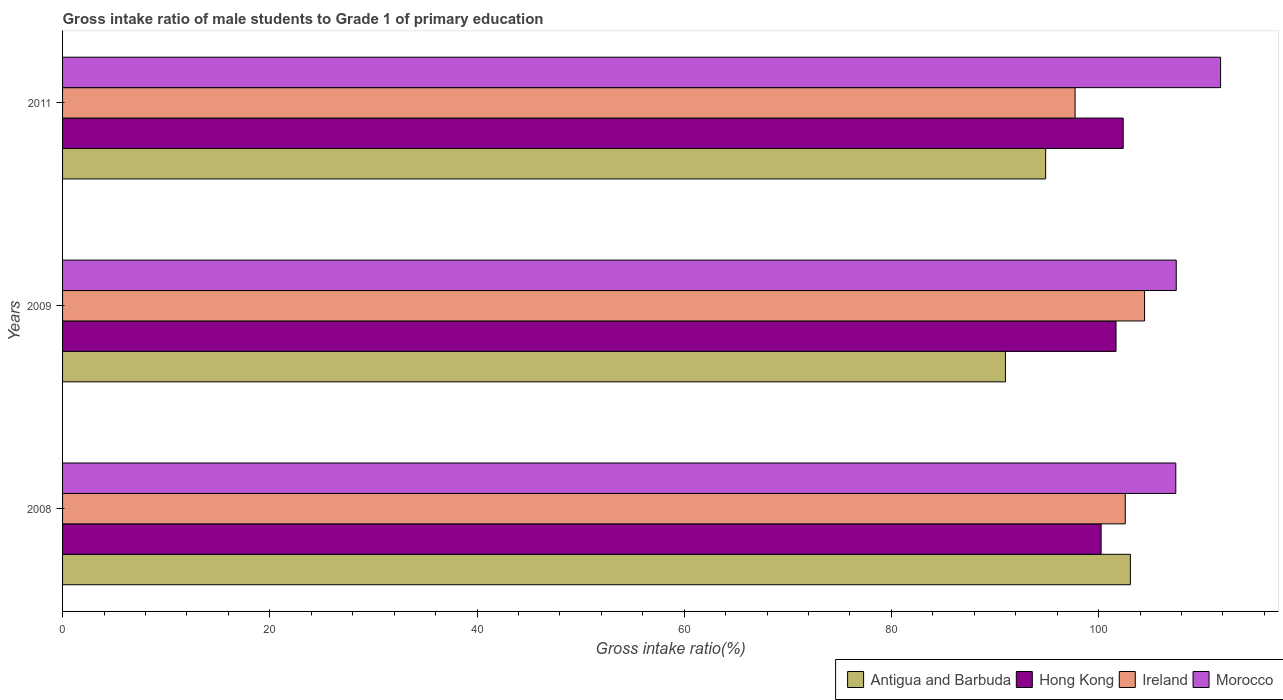How many different coloured bars are there?
Ensure brevity in your answer.  4. Are the number of bars on each tick of the Y-axis equal?
Keep it short and to the point. Yes. What is the label of the 3rd group of bars from the top?
Your response must be concise. 2008. What is the gross intake ratio in Morocco in 2008?
Offer a very short reply. 107.45. Across all years, what is the maximum gross intake ratio in Ireland?
Your response must be concise. 104.43. Across all years, what is the minimum gross intake ratio in Ireland?
Make the answer very short. 97.72. What is the total gross intake ratio in Antigua and Barbuda in the graph?
Keep it short and to the point. 288.95. What is the difference between the gross intake ratio in Morocco in 2008 and that in 2009?
Give a very brief answer. -0.04. What is the difference between the gross intake ratio in Hong Kong in 2011 and the gross intake ratio in Morocco in 2008?
Your answer should be very brief. -5.08. What is the average gross intake ratio in Morocco per year?
Ensure brevity in your answer.  108.9. In the year 2008, what is the difference between the gross intake ratio in Hong Kong and gross intake ratio in Antigua and Barbuda?
Your response must be concise. -2.82. In how many years, is the gross intake ratio in Ireland greater than 88 %?
Give a very brief answer. 3. What is the ratio of the gross intake ratio in Antigua and Barbuda in 2008 to that in 2009?
Your answer should be compact. 1.13. Is the gross intake ratio in Morocco in 2009 less than that in 2011?
Give a very brief answer. Yes. What is the difference between the highest and the second highest gross intake ratio in Ireland?
Provide a succinct answer. 1.87. What is the difference between the highest and the lowest gross intake ratio in Ireland?
Offer a terse response. 6.71. Is it the case that in every year, the sum of the gross intake ratio in Hong Kong and gross intake ratio in Morocco is greater than the sum of gross intake ratio in Ireland and gross intake ratio in Antigua and Barbuda?
Ensure brevity in your answer.  Yes. What does the 4th bar from the top in 2011 represents?
Your response must be concise. Antigua and Barbuda. What does the 4th bar from the bottom in 2008 represents?
Make the answer very short. Morocco. How many bars are there?
Give a very brief answer. 12. Are the values on the major ticks of X-axis written in scientific E-notation?
Make the answer very short. No. Does the graph contain any zero values?
Keep it short and to the point. No. How many legend labels are there?
Ensure brevity in your answer.  4. How are the legend labels stacked?
Offer a very short reply. Horizontal. What is the title of the graph?
Give a very brief answer. Gross intake ratio of male students to Grade 1 of primary education. What is the label or title of the X-axis?
Your response must be concise. Gross intake ratio(%). What is the Gross intake ratio(%) in Antigua and Barbuda in 2008?
Offer a very short reply. 103.06. What is the Gross intake ratio(%) in Hong Kong in 2008?
Provide a succinct answer. 100.24. What is the Gross intake ratio(%) in Ireland in 2008?
Provide a short and direct response. 102.57. What is the Gross intake ratio(%) of Morocco in 2008?
Provide a short and direct response. 107.45. What is the Gross intake ratio(%) in Antigua and Barbuda in 2009?
Make the answer very short. 91. What is the Gross intake ratio(%) of Hong Kong in 2009?
Make the answer very short. 101.68. What is the Gross intake ratio(%) of Ireland in 2009?
Your response must be concise. 104.43. What is the Gross intake ratio(%) in Morocco in 2009?
Offer a terse response. 107.49. What is the Gross intake ratio(%) of Antigua and Barbuda in 2011?
Provide a short and direct response. 94.89. What is the Gross intake ratio(%) in Hong Kong in 2011?
Your answer should be compact. 102.37. What is the Gross intake ratio(%) of Ireland in 2011?
Your response must be concise. 97.72. What is the Gross intake ratio(%) in Morocco in 2011?
Ensure brevity in your answer.  111.77. Across all years, what is the maximum Gross intake ratio(%) of Antigua and Barbuda?
Provide a succinct answer. 103.06. Across all years, what is the maximum Gross intake ratio(%) of Hong Kong?
Your answer should be very brief. 102.37. Across all years, what is the maximum Gross intake ratio(%) of Ireland?
Ensure brevity in your answer.  104.43. Across all years, what is the maximum Gross intake ratio(%) of Morocco?
Ensure brevity in your answer.  111.77. Across all years, what is the minimum Gross intake ratio(%) of Antigua and Barbuda?
Offer a very short reply. 91. Across all years, what is the minimum Gross intake ratio(%) of Hong Kong?
Provide a short and direct response. 100.24. Across all years, what is the minimum Gross intake ratio(%) of Ireland?
Ensure brevity in your answer.  97.72. Across all years, what is the minimum Gross intake ratio(%) in Morocco?
Your response must be concise. 107.45. What is the total Gross intake ratio(%) of Antigua and Barbuda in the graph?
Keep it short and to the point. 288.95. What is the total Gross intake ratio(%) of Hong Kong in the graph?
Your response must be concise. 304.29. What is the total Gross intake ratio(%) in Ireland in the graph?
Offer a terse response. 304.72. What is the total Gross intake ratio(%) of Morocco in the graph?
Ensure brevity in your answer.  326.7. What is the difference between the Gross intake ratio(%) of Antigua and Barbuda in 2008 and that in 2009?
Make the answer very short. 12.06. What is the difference between the Gross intake ratio(%) in Hong Kong in 2008 and that in 2009?
Your answer should be very brief. -1.44. What is the difference between the Gross intake ratio(%) in Ireland in 2008 and that in 2009?
Your response must be concise. -1.87. What is the difference between the Gross intake ratio(%) of Morocco in 2008 and that in 2009?
Make the answer very short. -0.04. What is the difference between the Gross intake ratio(%) in Antigua and Barbuda in 2008 and that in 2011?
Give a very brief answer. 8.18. What is the difference between the Gross intake ratio(%) in Hong Kong in 2008 and that in 2011?
Offer a very short reply. -2.13. What is the difference between the Gross intake ratio(%) in Ireland in 2008 and that in 2011?
Your response must be concise. 4.84. What is the difference between the Gross intake ratio(%) of Morocco in 2008 and that in 2011?
Your answer should be very brief. -4.32. What is the difference between the Gross intake ratio(%) of Antigua and Barbuda in 2009 and that in 2011?
Ensure brevity in your answer.  -3.88. What is the difference between the Gross intake ratio(%) of Hong Kong in 2009 and that in 2011?
Offer a terse response. -0.69. What is the difference between the Gross intake ratio(%) of Ireland in 2009 and that in 2011?
Provide a short and direct response. 6.71. What is the difference between the Gross intake ratio(%) in Morocco in 2009 and that in 2011?
Make the answer very short. -4.28. What is the difference between the Gross intake ratio(%) in Antigua and Barbuda in 2008 and the Gross intake ratio(%) in Hong Kong in 2009?
Give a very brief answer. 1.38. What is the difference between the Gross intake ratio(%) of Antigua and Barbuda in 2008 and the Gross intake ratio(%) of Ireland in 2009?
Keep it short and to the point. -1.37. What is the difference between the Gross intake ratio(%) in Antigua and Barbuda in 2008 and the Gross intake ratio(%) in Morocco in 2009?
Give a very brief answer. -4.43. What is the difference between the Gross intake ratio(%) in Hong Kong in 2008 and the Gross intake ratio(%) in Ireland in 2009?
Provide a short and direct response. -4.19. What is the difference between the Gross intake ratio(%) of Hong Kong in 2008 and the Gross intake ratio(%) of Morocco in 2009?
Keep it short and to the point. -7.25. What is the difference between the Gross intake ratio(%) in Ireland in 2008 and the Gross intake ratio(%) in Morocco in 2009?
Provide a succinct answer. -4.92. What is the difference between the Gross intake ratio(%) in Antigua and Barbuda in 2008 and the Gross intake ratio(%) in Hong Kong in 2011?
Provide a short and direct response. 0.69. What is the difference between the Gross intake ratio(%) of Antigua and Barbuda in 2008 and the Gross intake ratio(%) of Ireland in 2011?
Provide a succinct answer. 5.34. What is the difference between the Gross intake ratio(%) of Antigua and Barbuda in 2008 and the Gross intake ratio(%) of Morocco in 2011?
Your answer should be very brief. -8.71. What is the difference between the Gross intake ratio(%) in Hong Kong in 2008 and the Gross intake ratio(%) in Ireland in 2011?
Ensure brevity in your answer.  2.51. What is the difference between the Gross intake ratio(%) in Hong Kong in 2008 and the Gross intake ratio(%) in Morocco in 2011?
Ensure brevity in your answer.  -11.53. What is the difference between the Gross intake ratio(%) of Ireland in 2008 and the Gross intake ratio(%) of Morocco in 2011?
Offer a very short reply. -9.2. What is the difference between the Gross intake ratio(%) in Antigua and Barbuda in 2009 and the Gross intake ratio(%) in Hong Kong in 2011?
Make the answer very short. -11.37. What is the difference between the Gross intake ratio(%) of Antigua and Barbuda in 2009 and the Gross intake ratio(%) of Ireland in 2011?
Ensure brevity in your answer.  -6.72. What is the difference between the Gross intake ratio(%) of Antigua and Barbuda in 2009 and the Gross intake ratio(%) of Morocco in 2011?
Provide a succinct answer. -20.77. What is the difference between the Gross intake ratio(%) of Hong Kong in 2009 and the Gross intake ratio(%) of Ireland in 2011?
Keep it short and to the point. 3.95. What is the difference between the Gross intake ratio(%) in Hong Kong in 2009 and the Gross intake ratio(%) in Morocco in 2011?
Keep it short and to the point. -10.09. What is the difference between the Gross intake ratio(%) in Ireland in 2009 and the Gross intake ratio(%) in Morocco in 2011?
Provide a succinct answer. -7.34. What is the average Gross intake ratio(%) in Antigua and Barbuda per year?
Give a very brief answer. 96.32. What is the average Gross intake ratio(%) in Hong Kong per year?
Ensure brevity in your answer.  101.43. What is the average Gross intake ratio(%) in Ireland per year?
Give a very brief answer. 101.57. What is the average Gross intake ratio(%) in Morocco per year?
Provide a succinct answer. 108.9. In the year 2008, what is the difference between the Gross intake ratio(%) of Antigua and Barbuda and Gross intake ratio(%) of Hong Kong?
Ensure brevity in your answer.  2.82. In the year 2008, what is the difference between the Gross intake ratio(%) in Antigua and Barbuda and Gross intake ratio(%) in Ireland?
Provide a succinct answer. 0.49. In the year 2008, what is the difference between the Gross intake ratio(%) in Antigua and Barbuda and Gross intake ratio(%) in Morocco?
Your response must be concise. -4.38. In the year 2008, what is the difference between the Gross intake ratio(%) in Hong Kong and Gross intake ratio(%) in Ireland?
Your answer should be compact. -2.33. In the year 2008, what is the difference between the Gross intake ratio(%) in Hong Kong and Gross intake ratio(%) in Morocco?
Provide a succinct answer. -7.21. In the year 2008, what is the difference between the Gross intake ratio(%) in Ireland and Gross intake ratio(%) in Morocco?
Ensure brevity in your answer.  -4.88. In the year 2009, what is the difference between the Gross intake ratio(%) of Antigua and Barbuda and Gross intake ratio(%) of Hong Kong?
Give a very brief answer. -10.67. In the year 2009, what is the difference between the Gross intake ratio(%) of Antigua and Barbuda and Gross intake ratio(%) of Ireland?
Ensure brevity in your answer.  -13.43. In the year 2009, what is the difference between the Gross intake ratio(%) in Antigua and Barbuda and Gross intake ratio(%) in Morocco?
Provide a short and direct response. -16.48. In the year 2009, what is the difference between the Gross intake ratio(%) in Hong Kong and Gross intake ratio(%) in Ireland?
Give a very brief answer. -2.75. In the year 2009, what is the difference between the Gross intake ratio(%) of Hong Kong and Gross intake ratio(%) of Morocco?
Your response must be concise. -5.81. In the year 2009, what is the difference between the Gross intake ratio(%) of Ireland and Gross intake ratio(%) of Morocco?
Make the answer very short. -3.06. In the year 2011, what is the difference between the Gross intake ratio(%) in Antigua and Barbuda and Gross intake ratio(%) in Hong Kong?
Offer a terse response. -7.48. In the year 2011, what is the difference between the Gross intake ratio(%) of Antigua and Barbuda and Gross intake ratio(%) of Ireland?
Keep it short and to the point. -2.84. In the year 2011, what is the difference between the Gross intake ratio(%) in Antigua and Barbuda and Gross intake ratio(%) in Morocco?
Your response must be concise. -16.88. In the year 2011, what is the difference between the Gross intake ratio(%) of Hong Kong and Gross intake ratio(%) of Ireland?
Your answer should be very brief. 4.64. In the year 2011, what is the difference between the Gross intake ratio(%) of Hong Kong and Gross intake ratio(%) of Morocco?
Your response must be concise. -9.4. In the year 2011, what is the difference between the Gross intake ratio(%) in Ireland and Gross intake ratio(%) in Morocco?
Give a very brief answer. -14.04. What is the ratio of the Gross intake ratio(%) in Antigua and Barbuda in 2008 to that in 2009?
Give a very brief answer. 1.13. What is the ratio of the Gross intake ratio(%) in Hong Kong in 2008 to that in 2009?
Give a very brief answer. 0.99. What is the ratio of the Gross intake ratio(%) of Ireland in 2008 to that in 2009?
Keep it short and to the point. 0.98. What is the ratio of the Gross intake ratio(%) in Morocco in 2008 to that in 2009?
Provide a succinct answer. 1. What is the ratio of the Gross intake ratio(%) in Antigua and Barbuda in 2008 to that in 2011?
Keep it short and to the point. 1.09. What is the ratio of the Gross intake ratio(%) in Hong Kong in 2008 to that in 2011?
Offer a terse response. 0.98. What is the ratio of the Gross intake ratio(%) of Ireland in 2008 to that in 2011?
Ensure brevity in your answer.  1.05. What is the ratio of the Gross intake ratio(%) of Morocco in 2008 to that in 2011?
Give a very brief answer. 0.96. What is the ratio of the Gross intake ratio(%) of Antigua and Barbuda in 2009 to that in 2011?
Offer a very short reply. 0.96. What is the ratio of the Gross intake ratio(%) of Hong Kong in 2009 to that in 2011?
Keep it short and to the point. 0.99. What is the ratio of the Gross intake ratio(%) in Ireland in 2009 to that in 2011?
Offer a very short reply. 1.07. What is the ratio of the Gross intake ratio(%) in Morocco in 2009 to that in 2011?
Make the answer very short. 0.96. What is the difference between the highest and the second highest Gross intake ratio(%) of Antigua and Barbuda?
Ensure brevity in your answer.  8.18. What is the difference between the highest and the second highest Gross intake ratio(%) of Hong Kong?
Offer a terse response. 0.69. What is the difference between the highest and the second highest Gross intake ratio(%) of Ireland?
Your answer should be very brief. 1.87. What is the difference between the highest and the second highest Gross intake ratio(%) in Morocco?
Provide a succinct answer. 4.28. What is the difference between the highest and the lowest Gross intake ratio(%) of Antigua and Barbuda?
Your response must be concise. 12.06. What is the difference between the highest and the lowest Gross intake ratio(%) of Hong Kong?
Provide a short and direct response. 2.13. What is the difference between the highest and the lowest Gross intake ratio(%) of Ireland?
Your answer should be very brief. 6.71. What is the difference between the highest and the lowest Gross intake ratio(%) in Morocco?
Give a very brief answer. 4.32. 